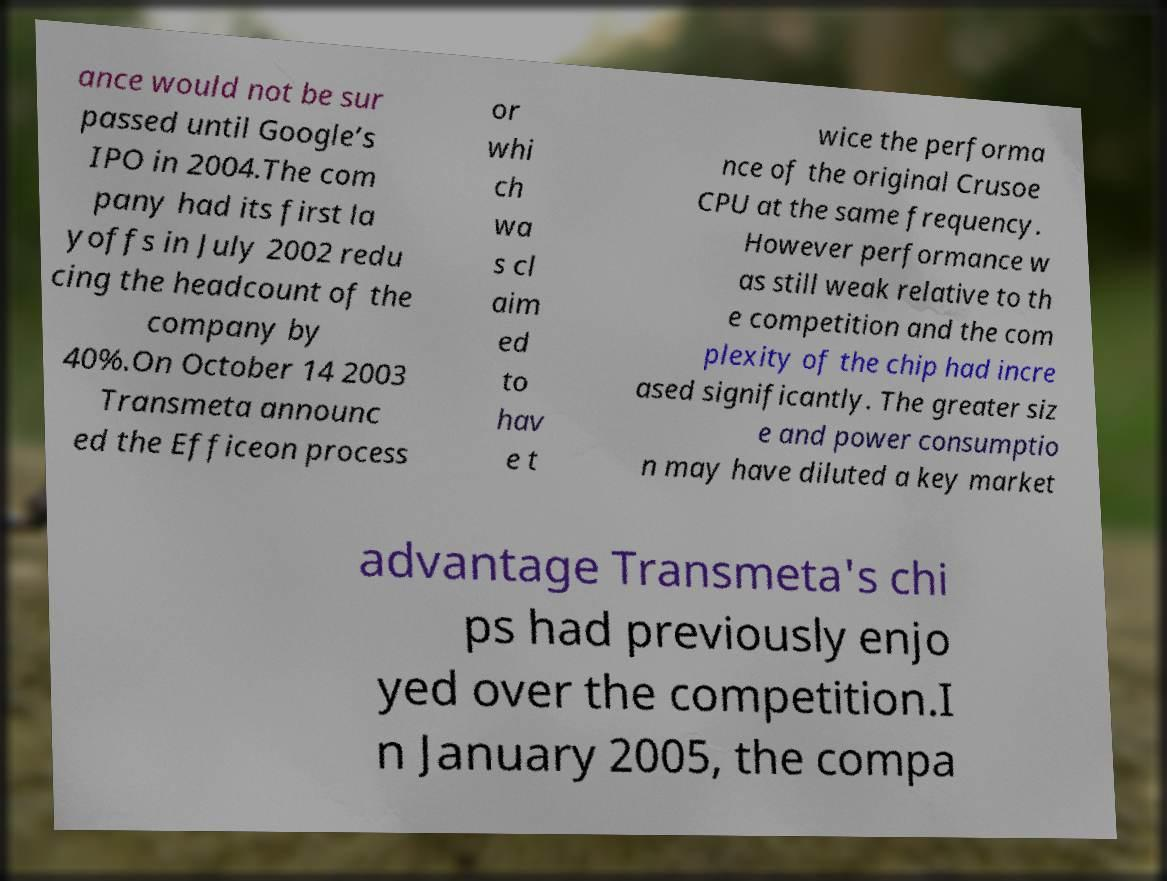For documentation purposes, I need the text within this image transcribed. Could you provide that? ance would not be sur passed until Google’s IPO in 2004.The com pany had its first la yoffs in July 2002 redu cing the headcount of the company by 40%.On October 14 2003 Transmeta announc ed the Efficeon process or whi ch wa s cl aim ed to hav e t wice the performa nce of the original Crusoe CPU at the same frequency. However performance w as still weak relative to th e competition and the com plexity of the chip had incre ased significantly. The greater siz e and power consumptio n may have diluted a key market advantage Transmeta's chi ps had previously enjo yed over the competition.I n January 2005, the compa 